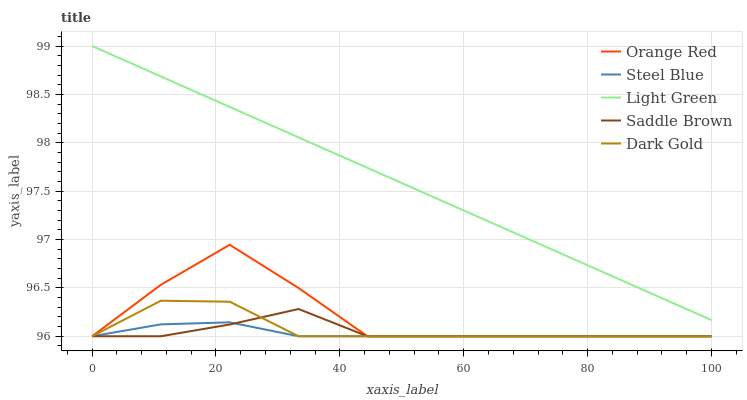Does Steel Blue have the minimum area under the curve?
Answer yes or no. Yes. Does Light Green have the maximum area under the curve?
Answer yes or no. Yes. Does Dark Gold have the minimum area under the curve?
Answer yes or no. No. Does Dark Gold have the maximum area under the curve?
Answer yes or no. No. Is Light Green the smoothest?
Answer yes or no. Yes. Is Orange Red the roughest?
Answer yes or no. Yes. Is Dark Gold the smoothest?
Answer yes or no. No. Is Dark Gold the roughest?
Answer yes or no. No. Does Light Green have the lowest value?
Answer yes or no. No. Does Light Green have the highest value?
Answer yes or no. Yes. Does Dark Gold have the highest value?
Answer yes or no. No. Is Steel Blue less than Light Green?
Answer yes or no. Yes. Is Light Green greater than Dark Gold?
Answer yes or no. Yes. Does Orange Red intersect Steel Blue?
Answer yes or no. Yes. Is Orange Red less than Steel Blue?
Answer yes or no. No. Is Orange Red greater than Steel Blue?
Answer yes or no. No. Does Steel Blue intersect Light Green?
Answer yes or no. No. 